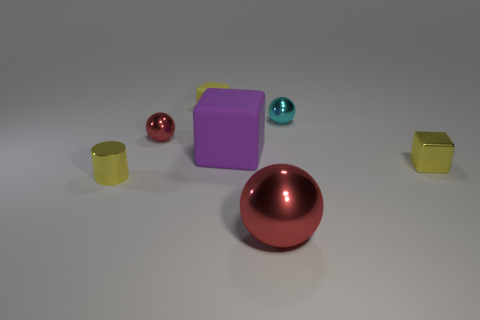There is a cylinder that is the same color as the small matte cube; what material is it?
Offer a very short reply. Metal. Are there any purple cubes that have the same size as the cyan metal sphere?
Offer a terse response. No. Are there more red things in front of the yellow metal cube than small red metal objects behind the tiny matte thing?
Your answer should be compact. Yes. Is the material of the tiny yellow object that is to the right of the large red ball the same as the big object behind the large ball?
Your answer should be very brief. No. The cyan metallic object that is the same size as the metallic cylinder is what shape?
Offer a terse response. Sphere. Are there any other things of the same shape as the big red thing?
Your response must be concise. Yes. There is a big thing that is in front of the tiny yellow cylinder; is it the same color as the small metal cube right of the small yellow rubber thing?
Give a very brief answer. No. There is a small red ball; are there any spheres in front of it?
Ensure brevity in your answer.  Yes. What material is the tiny thing that is both right of the small rubber block and in front of the small red metal thing?
Your answer should be very brief. Metal. Are the tiny yellow thing in front of the tiny yellow metallic cube and the large purple cube made of the same material?
Ensure brevity in your answer.  No. 